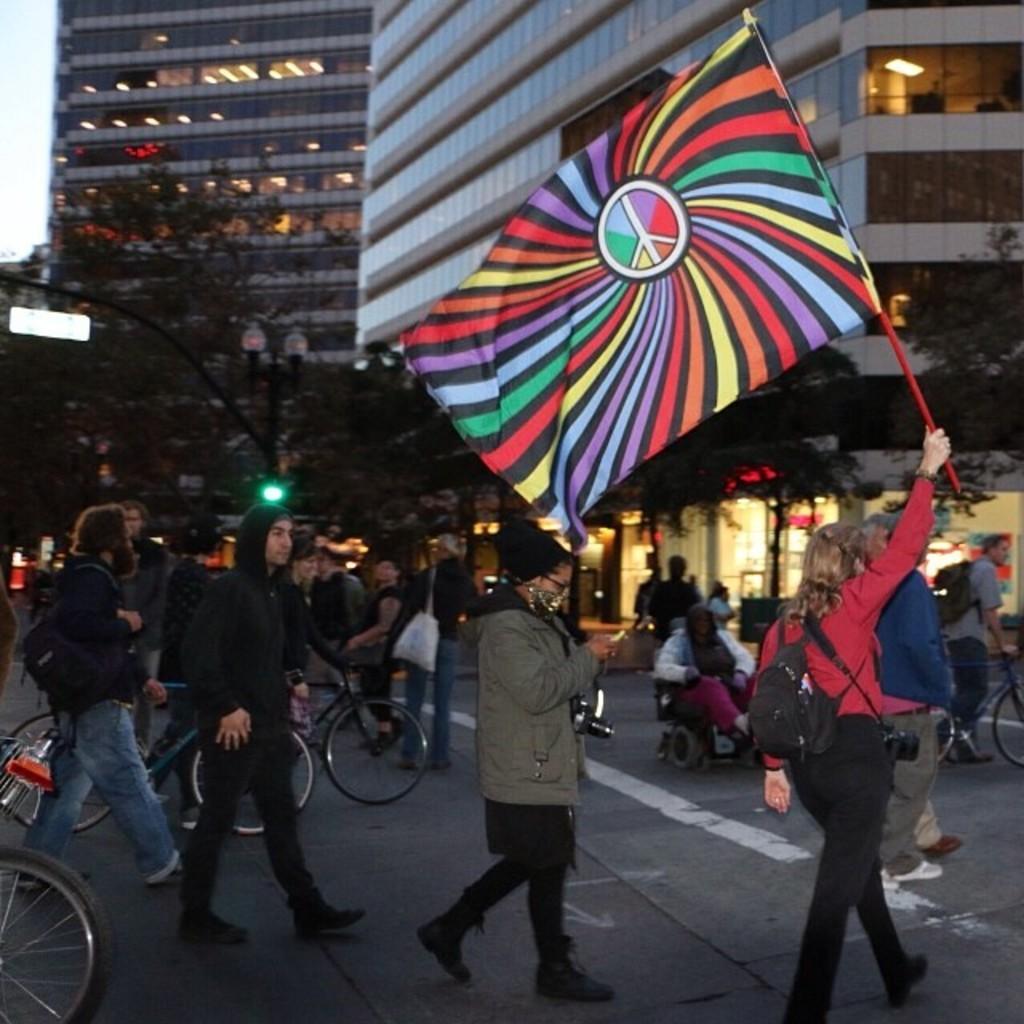Please provide a concise description of this image. In this picture we can see a group of people walking, bicycles on the road and some people are carrying bags, cameras and a woman holding a flag with her hand and in the background we can see a wheelchair, trees, poles, name board, lights, buildings and some objects. 